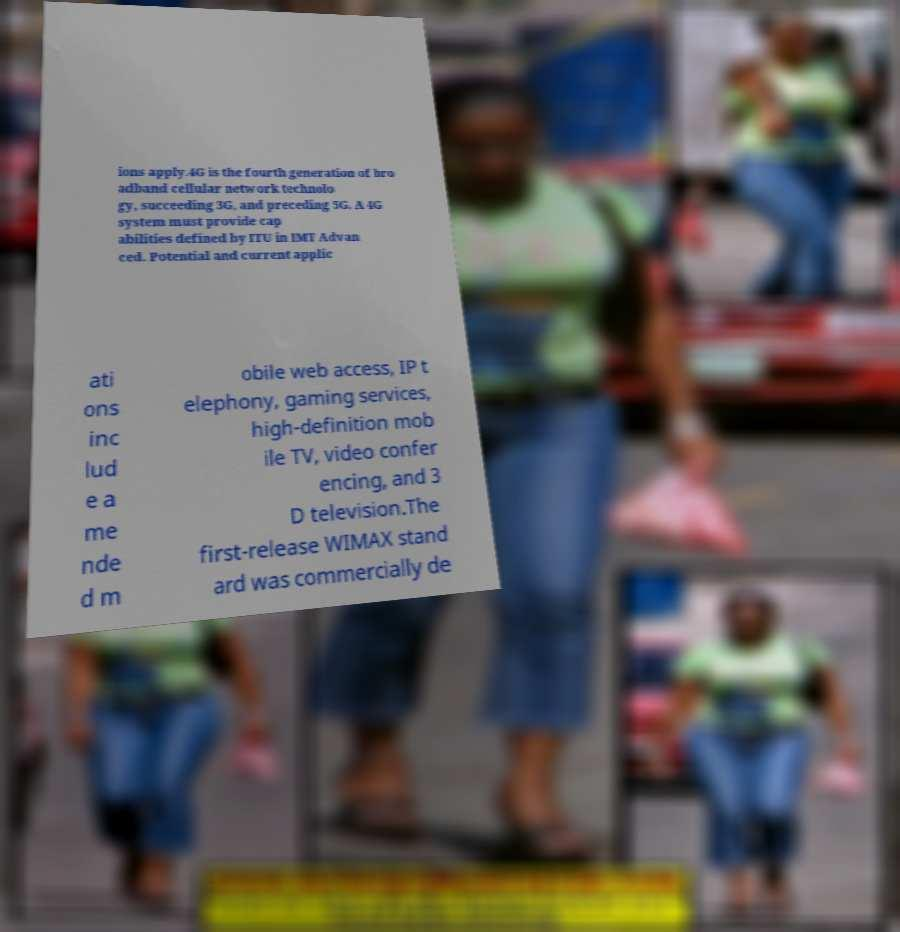Can you accurately transcribe the text from the provided image for me? ions apply.4G is the fourth generation of bro adband cellular network technolo gy, succeeding 3G, and preceding 5G. A 4G system must provide cap abilities defined by ITU in IMT Advan ced. Potential and current applic ati ons inc lud e a me nde d m obile web access, IP t elephony, gaming services, high-definition mob ile TV, video confer encing, and 3 D television.The first-release WIMAX stand ard was commercially de 